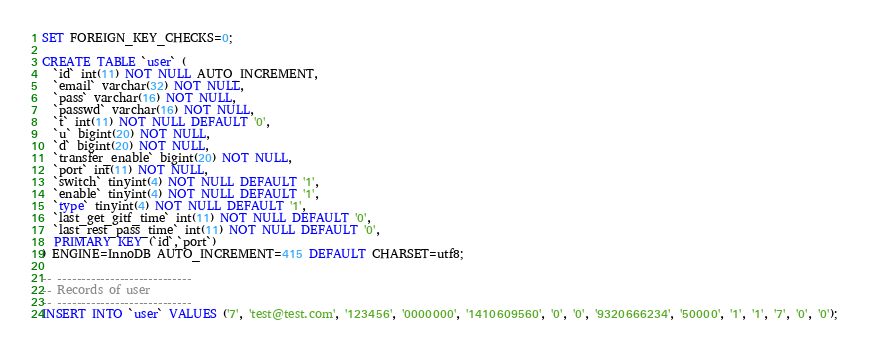<code> <loc_0><loc_0><loc_500><loc_500><_SQL_>SET FOREIGN_KEY_CHECKS=0;

CREATE TABLE `user` (
  `id` int(11) NOT NULL AUTO_INCREMENT,
  `email` varchar(32) NOT NULL,
  `pass` varchar(16) NOT NULL,
  `passwd` varchar(16) NOT NULL,
  `t` int(11) NOT NULL DEFAULT '0',
  `u` bigint(20) NOT NULL,
  `d` bigint(20) NOT NULL,
  `transfer_enable` bigint(20) NOT NULL,
  `port` int(11) NOT NULL,
  `switch` tinyint(4) NOT NULL DEFAULT '1',
  `enable` tinyint(4) NOT NULL DEFAULT '1',
  `type` tinyint(4) NOT NULL DEFAULT '1',
  `last_get_gitf_time` int(11) NOT NULL DEFAULT '0',
  `last_rest_pass_time` int(11) NOT NULL DEFAULT '0',
  PRIMARY KEY (`id`,`port`)
) ENGINE=InnoDB AUTO_INCREMENT=415 DEFAULT CHARSET=utf8;

-- ----------------------------
-- Records of user
-- ----------------------------
INSERT INTO `user` VALUES ('7', 'test@test.com', '123456', '0000000', '1410609560', '0', '0', '9320666234', '50000', '1', '1', '7', '0', '0');</code> 